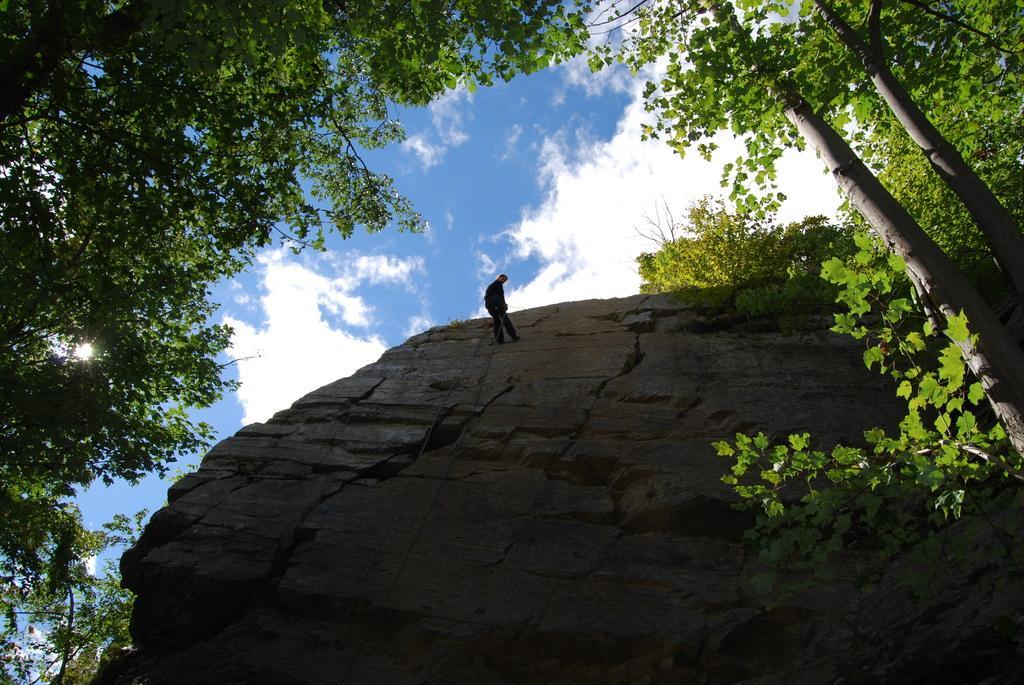Can you describe this image briefly? In the image we can see there is a person standing on the rock hill and there are lot of trees. There is a cloudy sky. 